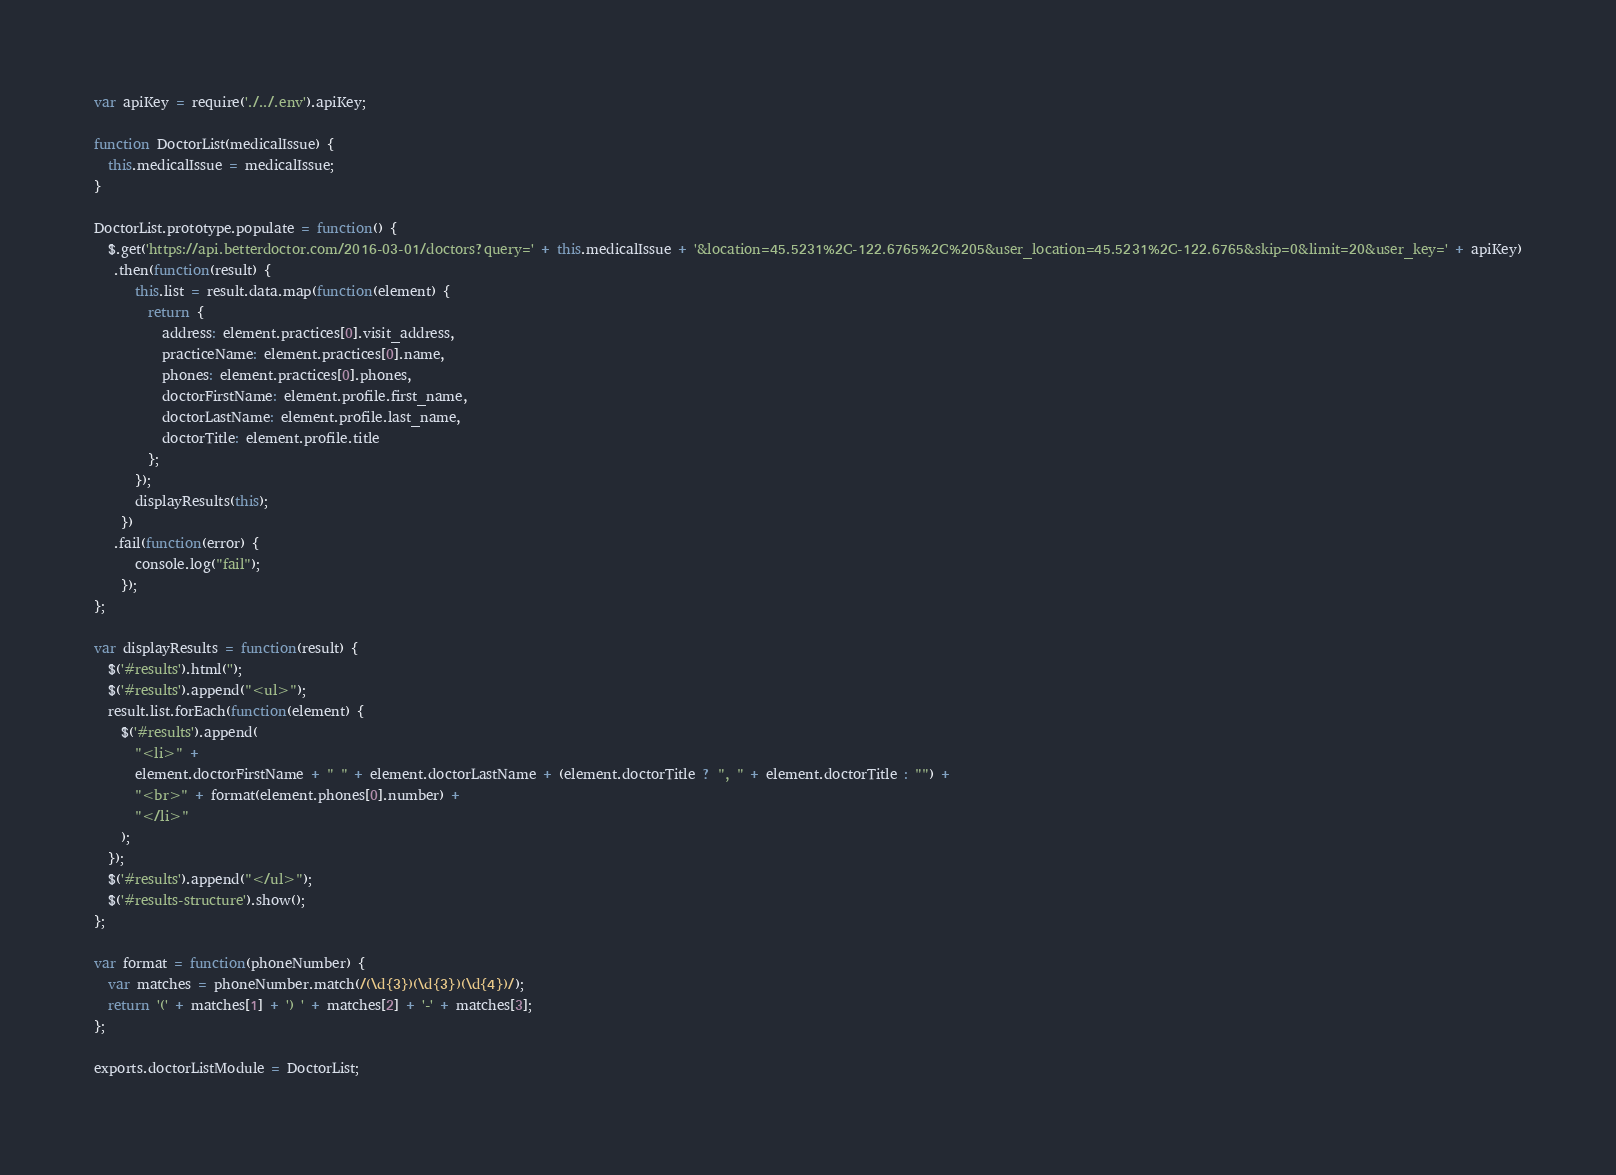Convert code to text. <code><loc_0><loc_0><loc_500><loc_500><_JavaScript_>var apiKey = require('./../.env').apiKey;

function DoctorList(medicalIssue) {
  this.medicalIssue = medicalIssue;
}

DoctorList.prototype.populate = function() {
  $.get('https://api.betterdoctor.com/2016-03-01/doctors?query=' + this.medicalIssue + '&location=45.5231%2C-122.6765%2C%205&user_location=45.5231%2C-122.6765&skip=0&limit=20&user_key=' + apiKey)
   .then(function(result) {
      this.list = result.data.map(function(element) {
        return {
          address: element.practices[0].visit_address,
          practiceName: element.practices[0].name,
          phones: element.practices[0].phones,
          doctorFirstName: element.profile.first_name,
          doctorLastName: element.profile.last_name,
          doctorTitle: element.profile.title
        };
      });
      displayResults(this);
    })
   .fail(function(error) {
      console.log("fail");
    });
};

var displayResults = function(result) {
  $('#results').html('');
  $('#results').append("<ul>");
  result.list.forEach(function(element) {
    $('#results').append(
      "<li>" +
      element.doctorFirstName + " " + element.doctorLastName + (element.doctorTitle ? ", " + element.doctorTitle : "") +
      "<br>" + format(element.phones[0].number) +
      "</li>"
    );
  });
  $('#results').append("</ul>");
  $('#results-structure').show();
};

var format = function(phoneNumber) {
  var matches = phoneNumber.match(/(\d{3})(\d{3})(\d{4})/);
  return '(' + matches[1] + ') ' + matches[2] + '-' + matches[3];
};

exports.doctorListModule = DoctorList;
</code> 